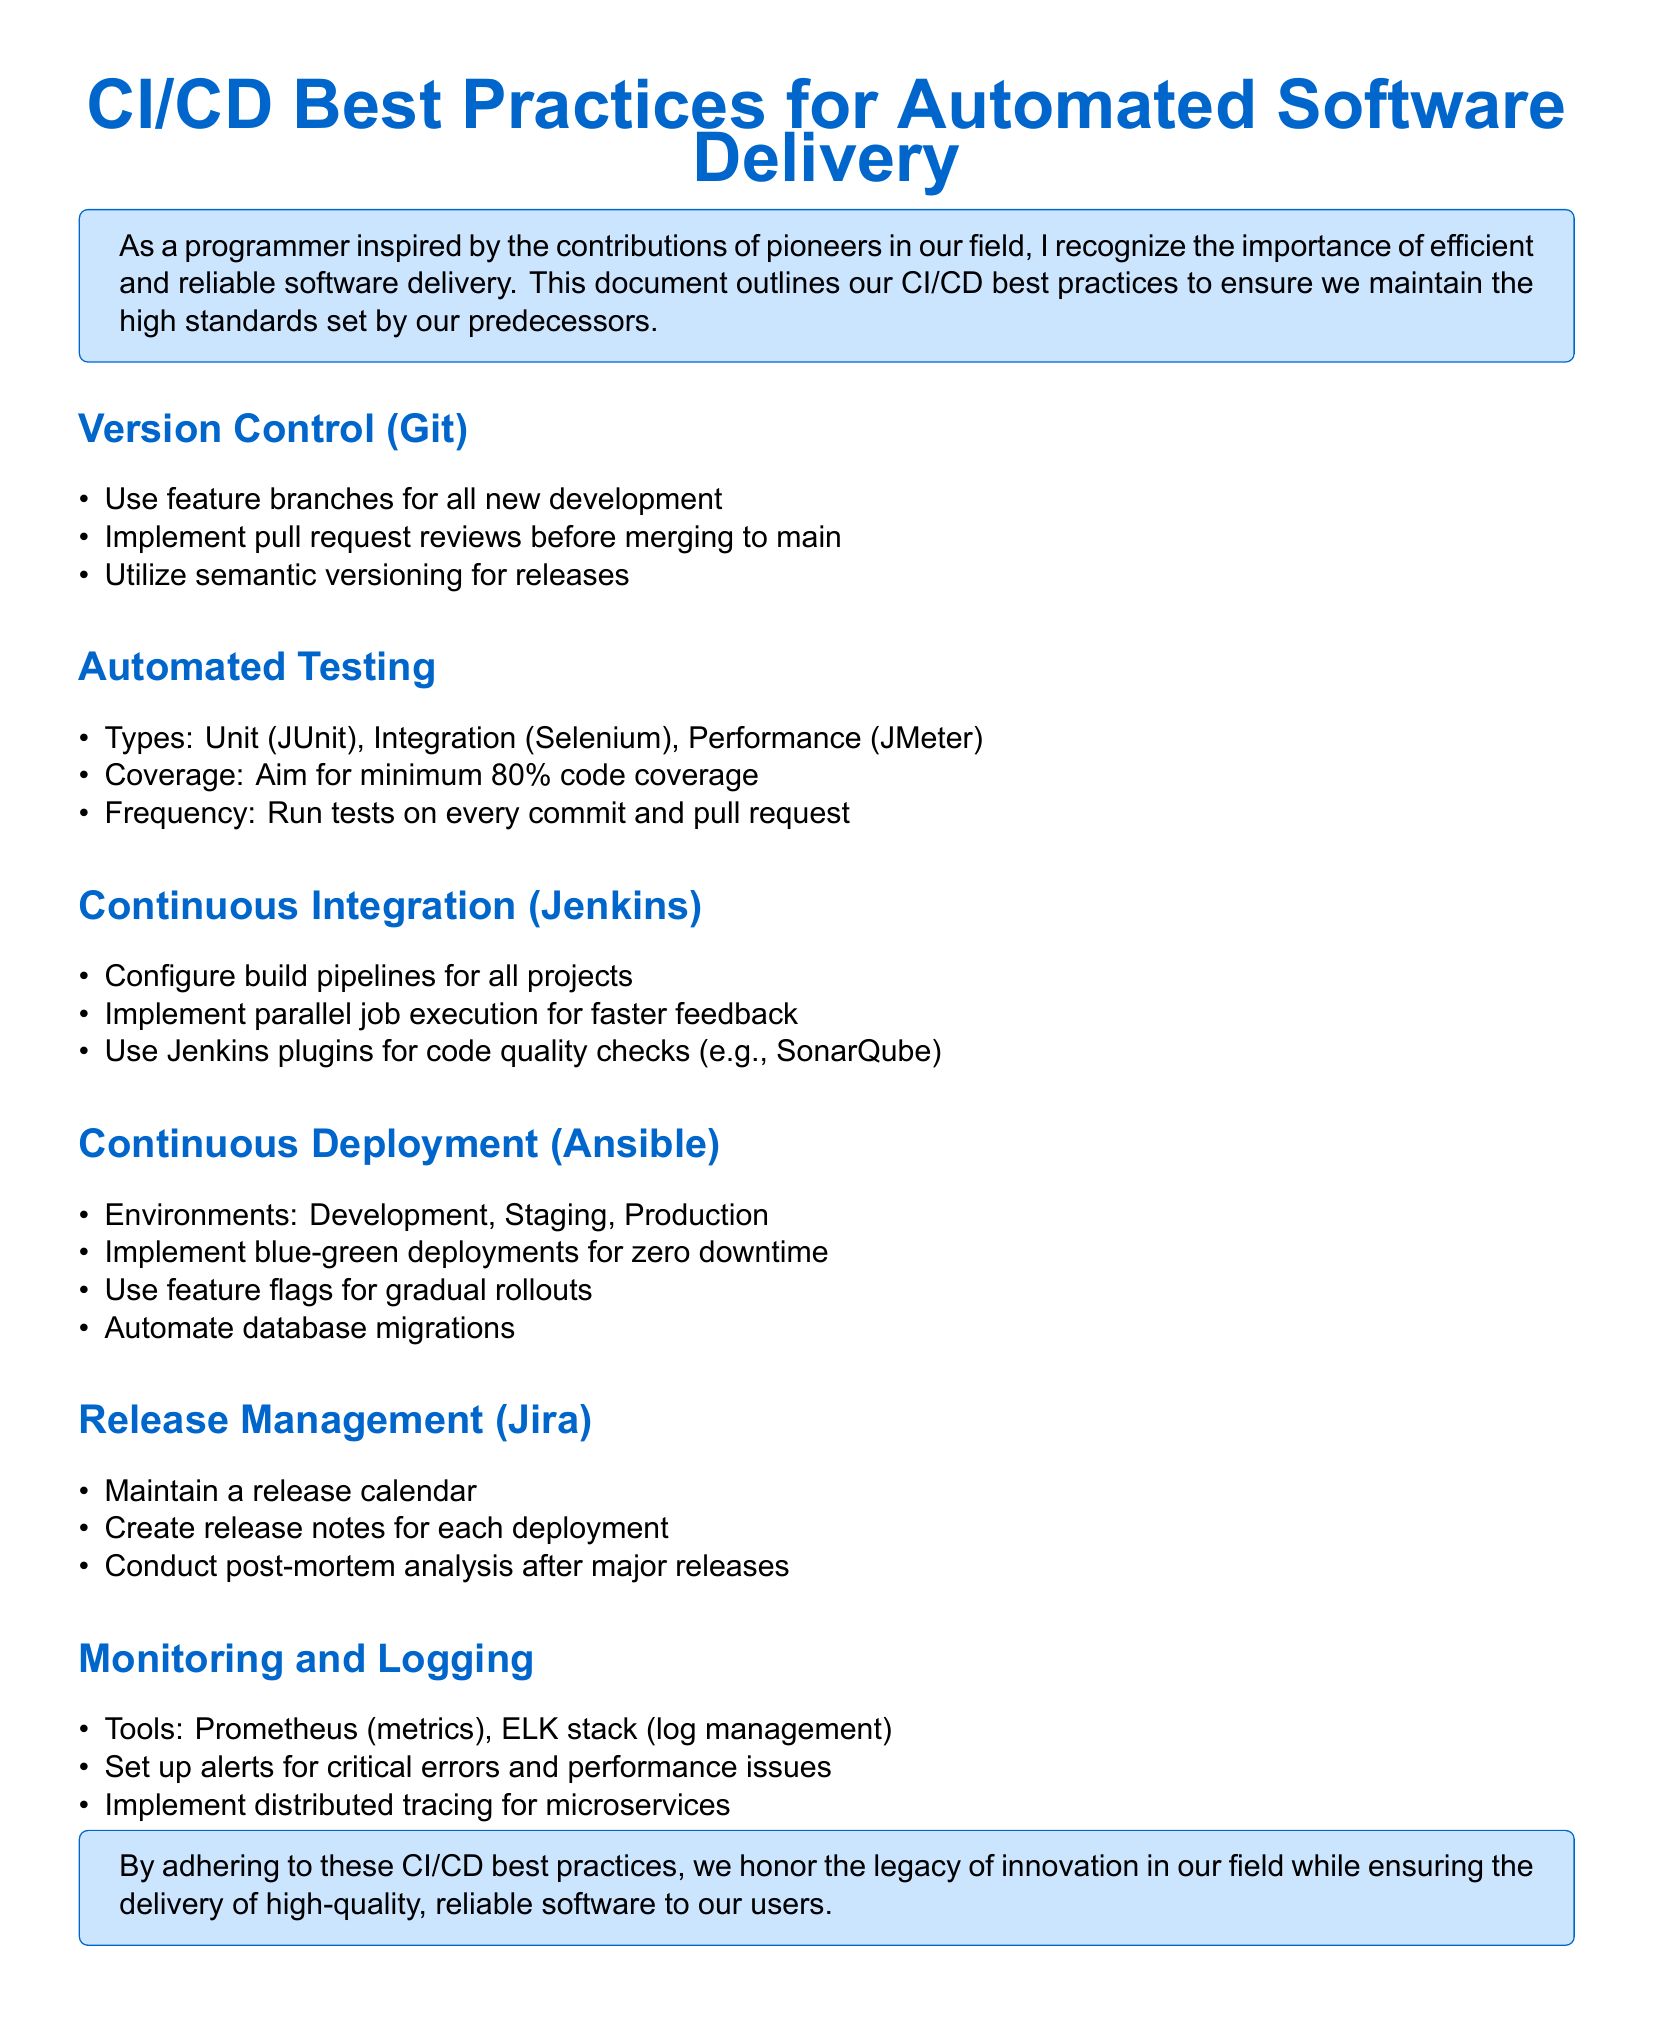What is the minimum code coverage target for automated testing? The document specifies aiming for a minimum of 80% code coverage.
Answer: 80% What version control system is recommended? The document mentions using Git for version control.
Answer: Git What type of deployments does the document recommend for zero downtime? The document suggests implementing blue-green deployments.
Answer: blue-green deployments Which tool is mentioned for continuous integration? Jenkins is highlighted as the tool for continuous integration in the document.
Answer: Jenkins What should be maintained for release management? The document states to maintain a release calendar.
Answer: release calendar What is the frequency of running tests according to the document? The document states tests should be run on every commit and pull request.
Answer: every commit and pull request Which tool is suggested for log management? The document lists the ELK stack for log management.
Answer: ELK stack How many environments are mentioned under continuous deployment? The document mentions three environments: Development, Staging, and Production.
Answer: three What type of analysis should be conducted after major releases? The document indicates that a post-mortem analysis should be conducted after major releases.
Answer: post-mortem analysis 